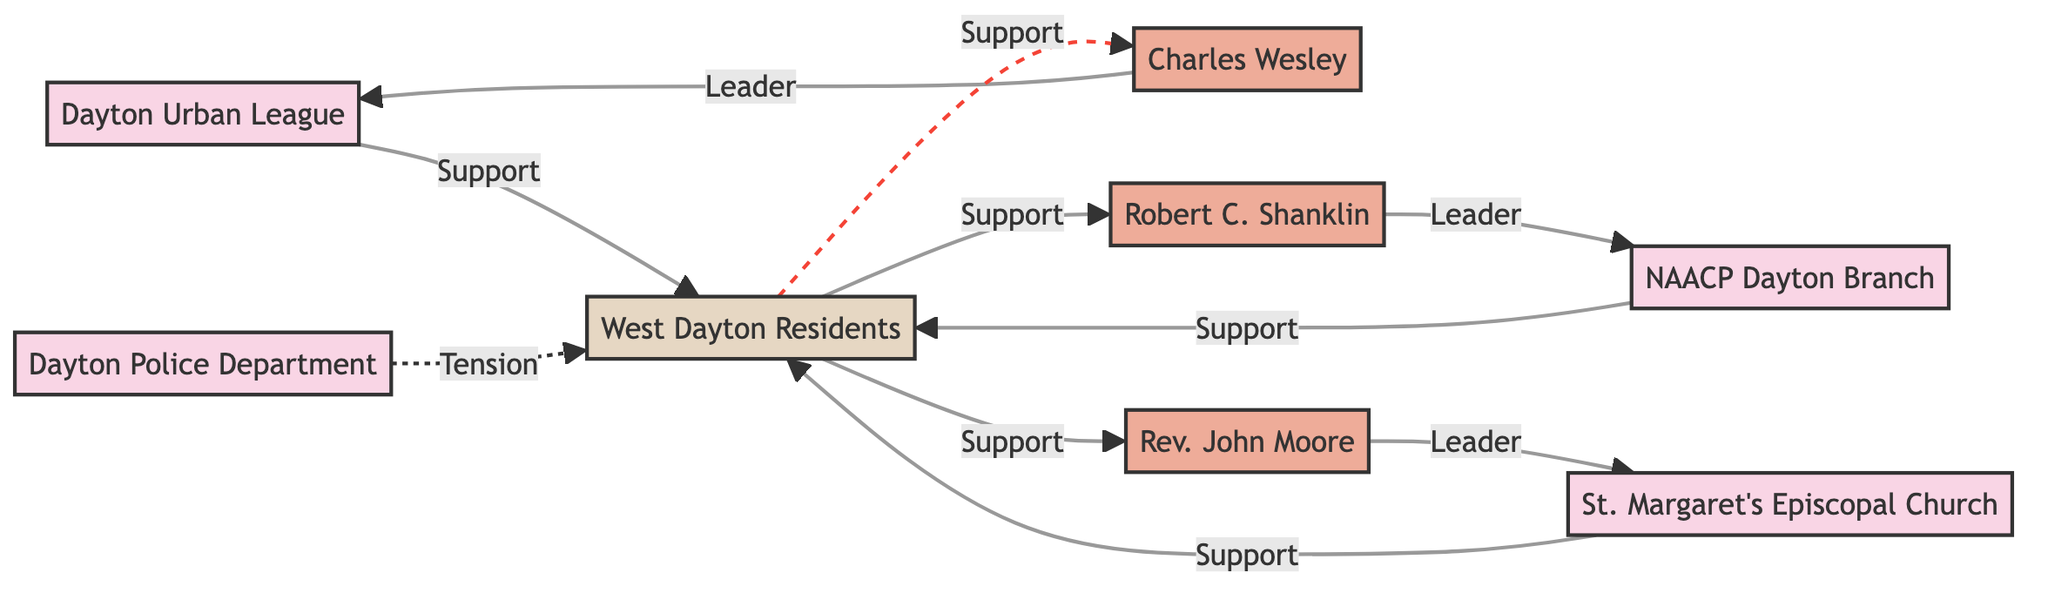What is the total number of nodes in the diagram? The diagram includes multiple entities represented as nodes. Counting each node listed—Dayton Urban League, NAACP Dayton Branch, St. Margaret's Episcopal Church, Charles Wesley, Robert C. Shanklin, Rev. John Moore, West Dayton Residents, and Dayton Police Department—there are a total of 8 nodes.
Answer: 8 Which organization is supported by West Dayton Residents? The diagram indicates associations through edges. The West Dayton Residents have support connections to several organizations: Dayton Urban League, NAACP Dayton Branch, and St. Margaret's Episcopal Church. Therefore, all three organizations are supported by West Dayton Residents.
Answer: Dayton Urban League, NAACP Dayton Branch, St. Margaret's Episcopal Church Who is the leader of the Dayton Urban League? The diagram specifies the relationship between Charles Wesley and the Dayton Urban League, marking him as the leader of the organization. Specifically, there is an edge connecting Charles Wesley to the Dayton Urban League labeled "Leader."
Answer: Charles Wesley What type of relationship exists between the Dayton Police Department and West Dayton Residents? The diagram describes the relationship between the Dayton Police Department and West Dayton Residents with a dashed line, indicating tension. The edge is labeled "Tension," highlighting the conflict or strain in their relationship during the described period.
Answer: Tension Which community group receives support from Rev. John Moore? The diagram depicts a supportive relationship between Rev. John Moore and West Dayton Residents. There is a direct connection from the community group (West Dayton Residents) to Rev. John Moore along with the label "Support," illustrating that he has a supportive role regarding this community.
Answer: West Dayton Residents How many leaders are identified in the diagram? The diagram shows that there are three individuals identified as leaders through their connections to specific organizations: Charles Wesley (Dayton Urban League), Robert C. Shanklin (NAACP Dayton Branch), and Rev. John Moore (St. Margaret's Episcopal Church). Therefore, counting these individuals results in three leaders identified within the diagram.
Answer: 3 